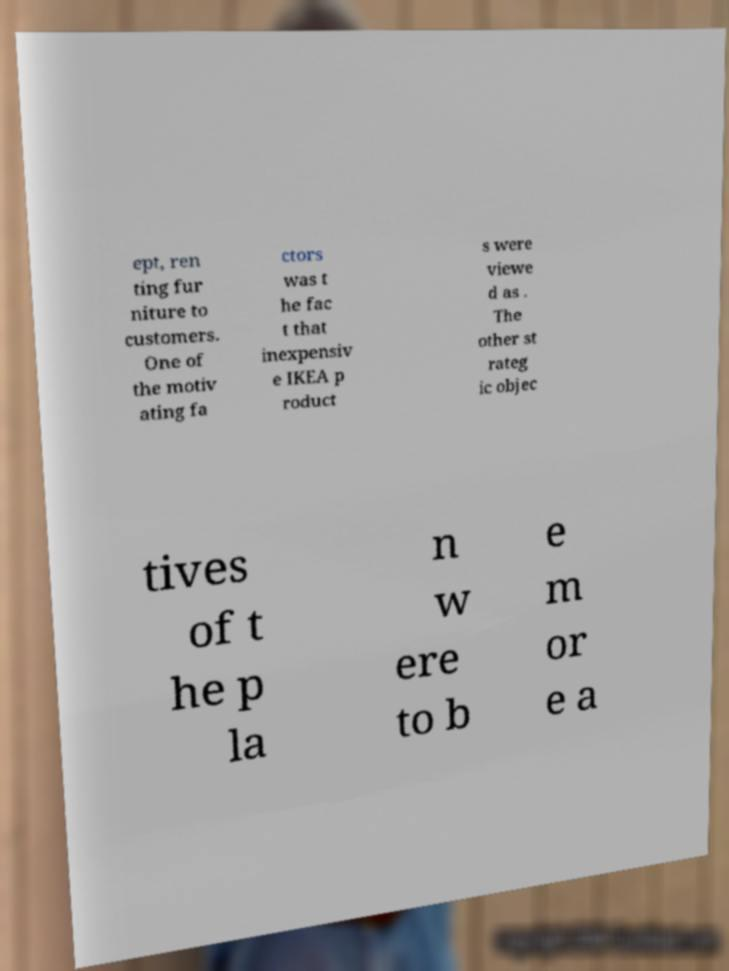Can you read and provide the text displayed in the image?This photo seems to have some interesting text. Can you extract and type it out for me? ept, ren ting fur niture to customers. One of the motiv ating fa ctors was t he fac t that inexpensiv e IKEA p roduct s were viewe d as . The other st rateg ic objec tives of t he p la n w ere to b e m or e a 